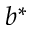Convert formula to latex. <formula><loc_0><loc_0><loc_500><loc_500>b ^ { * }</formula> 